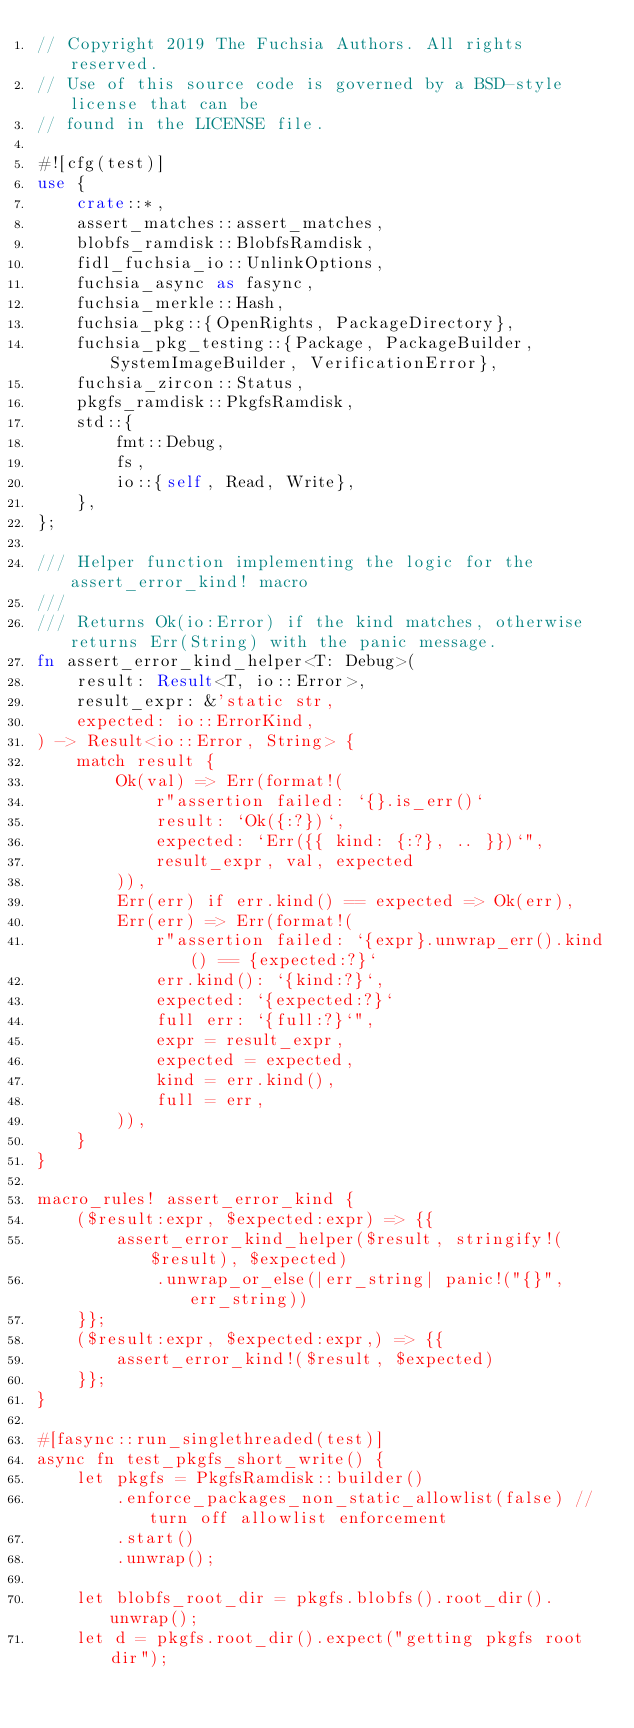<code> <loc_0><loc_0><loc_500><loc_500><_Rust_>// Copyright 2019 The Fuchsia Authors. All rights reserved.
// Use of this source code is governed by a BSD-style license that can be
// found in the LICENSE file.

#![cfg(test)]
use {
    crate::*,
    assert_matches::assert_matches,
    blobfs_ramdisk::BlobfsRamdisk,
    fidl_fuchsia_io::UnlinkOptions,
    fuchsia_async as fasync,
    fuchsia_merkle::Hash,
    fuchsia_pkg::{OpenRights, PackageDirectory},
    fuchsia_pkg_testing::{Package, PackageBuilder, SystemImageBuilder, VerificationError},
    fuchsia_zircon::Status,
    pkgfs_ramdisk::PkgfsRamdisk,
    std::{
        fmt::Debug,
        fs,
        io::{self, Read, Write},
    },
};

/// Helper function implementing the logic for the assert_error_kind! macro
///
/// Returns Ok(io:Error) if the kind matches, otherwise returns Err(String) with the panic message.
fn assert_error_kind_helper<T: Debug>(
    result: Result<T, io::Error>,
    result_expr: &'static str,
    expected: io::ErrorKind,
) -> Result<io::Error, String> {
    match result {
        Ok(val) => Err(format!(
            r"assertion failed: `{}.is_err()`
            result: `Ok({:?})`,
            expected: `Err({{ kind: {:?}, .. }})`",
            result_expr, val, expected
        )),
        Err(err) if err.kind() == expected => Ok(err),
        Err(err) => Err(format!(
            r"assertion failed: `{expr}.unwrap_err().kind() == {expected:?}`
            err.kind(): `{kind:?}`,
            expected: `{expected:?}`
            full err: `{full:?}`",
            expr = result_expr,
            expected = expected,
            kind = err.kind(),
            full = err,
        )),
    }
}

macro_rules! assert_error_kind {
    ($result:expr, $expected:expr) => {{
        assert_error_kind_helper($result, stringify!($result), $expected)
            .unwrap_or_else(|err_string| panic!("{}", err_string))
    }};
    ($result:expr, $expected:expr,) => {{
        assert_error_kind!($result, $expected)
    }};
}

#[fasync::run_singlethreaded(test)]
async fn test_pkgfs_short_write() {
    let pkgfs = PkgfsRamdisk::builder()
        .enforce_packages_non_static_allowlist(false) // turn off allowlist enforcement
        .start()
        .unwrap();

    let blobfs_root_dir = pkgfs.blobfs().root_dir().unwrap();
    let d = pkgfs.root_dir().expect("getting pkgfs root dir");
</code> 